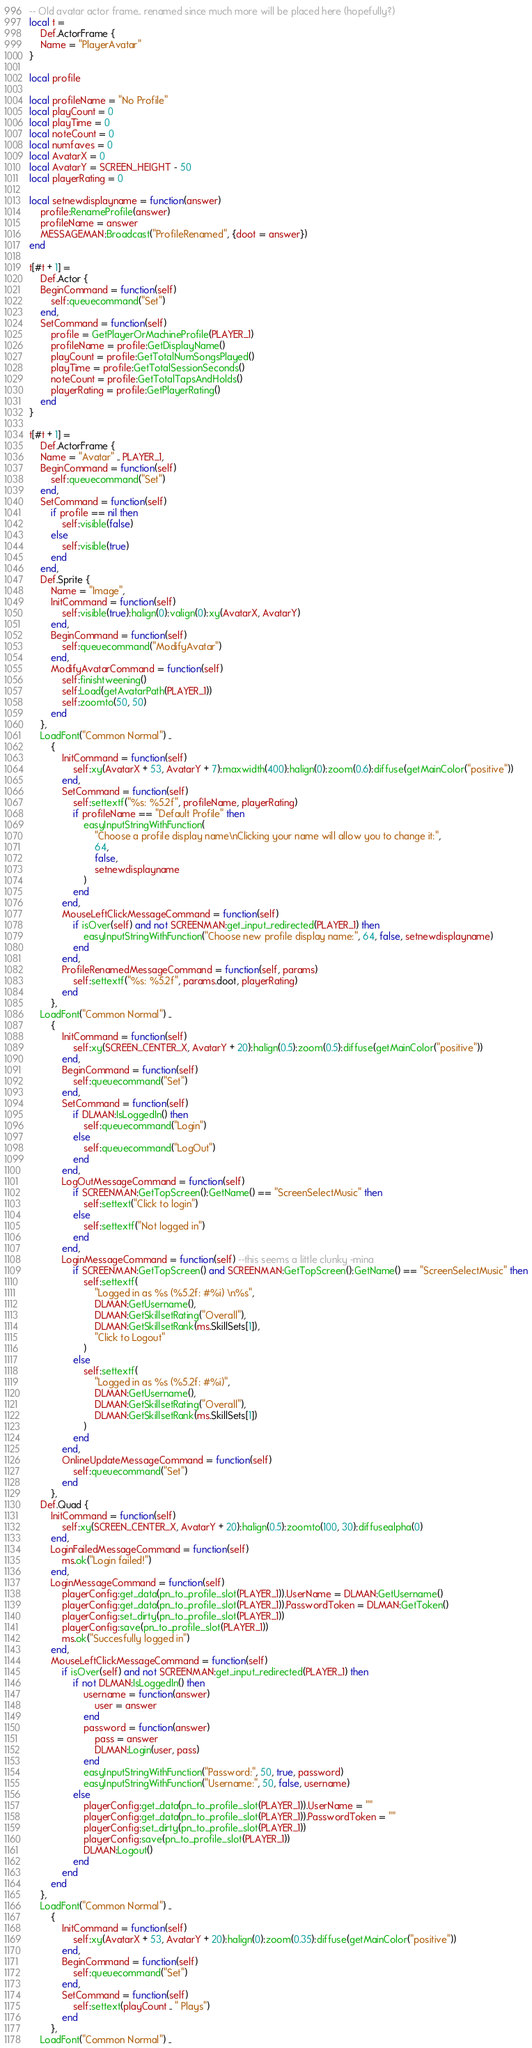<code> <loc_0><loc_0><loc_500><loc_500><_Lua_>-- Old avatar actor frame.. renamed since much more will be placed here (hopefully?)
local t =
	Def.ActorFrame {
	Name = "PlayerAvatar"
}

local profile

local profileName = "No Profile"
local playCount = 0
local playTime = 0
local noteCount = 0
local numfaves = 0
local AvatarX = 0
local AvatarY = SCREEN_HEIGHT - 50
local playerRating = 0

local setnewdisplayname = function(answer)
	profile:RenameProfile(answer)
	profileName = answer
	MESSAGEMAN:Broadcast("ProfileRenamed", {doot = answer})
end

t[#t + 1] =
	Def.Actor {
	BeginCommand = function(self)
		self:queuecommand("Set")
	end,
	SetCommand = function(self)
		profile = GetPlayerOrMachineProfile(PLAYER_1)
		profileName = profile:GetDisplayName()
		playCount = profile:GetTotalNumSongsPlayed()
		playTime = profile:GetTotalSessionSeconds()
		noteCount = profile:GetTotalTapsAndHolds()
		playerRating = profile:GetPlayerRating()
	end
}

t[#t + 1] =
	Def.ActorFrame {
	Name = "Avatar" .. PLAYER_1,
	BeginCommand = function(self)
		self:queuecommand("Set")
	end,
	SetCommand = function(self)
		if profile == nil then
			self:visible(false)
		else
			self:visible(true)
		end
	end,
	Def.Sprite {
		Name = "Image",
		InitCommand = function(self)
			self:visible(true):halign(0):valign(0):xy(AvatarX, AvatarY)
		end,
		BeginCommand = function(self)
			self:queuecommand("ModifyAvatar")
		end,
		ModifyAvatarCommand = function(self)
			self:finishtweening()
			self:Load(getAvatarPath(PLAYER_1))
			self:zoomto(50, 50)
		end
	},
	LoadFont("Common Normal") ..
		{
			InitCommand = function(self)
				self:xy(AvatarX + 53, AvatarY + 7):maxwidth(400):halign(0):zoom(0.6):diffuse(getMainColor("positive"))
			end,
			SetCommand = function(self)
				self:settextf("%s: %5.2f", profileName, playerRating)
				if profileName == "Default Profile" then
					easyInputStringWithFunction(
						"Choose a profile display name\nClicking your name will allow you to change it:",
						64,
						false,
						setnewdisplayname
					)
				end
			end,
			MouseLeftClickMessageCommand = function(self)
				if isOver(self) and not SCREENMAN:get_input_redirected(PLAYER_1) then
					easyInputStringWithFunction("Choose new profile display name:", 64, false, setnewdisplayname)
				end
			end,
			ProfileRenamedMessageCommand = function(self, params)
				self:settextf("%s: %5.2f", params.doot, playerRating)
			end
		},
	LoadFont("Common Normal") ..
		{
			InitCommand = function(self)
				self:xy(SCREEN_CENTER_X, AvatarY + 20):halign(0.5):zoom(0.5):diffuse(getMainColor("positive"))
			end,
			BeginCommand = function(self)
				self:queuecommand("Set")
			end,
			SetCommand = function(self)
				if DLMAN:IsLoggedIn() then
					self:queuecommand("Login")
				else
					self:queuecommand("LogOut")
				end
			end,
			LogOutMessageCommand = function(self)
				if SCREENMAN:GetTopScreen():GetName() == "ScreenSelectMusic" then
					self:settext("Click to login")
				else
					self:settextf("Not logged in")
				end
			end,
			LoginMessageCommand = function(self) --this seems a little clunky -mina
				if SCREENMAN:GetTopScreen() and SCREENMAN:GetTopScreen():GetName() == "ScreenSelectMusic" then
					self:settextf(
						"Logged in as %s (%5.2f: #%i) \n%s",
						DLMAN:GetUsername(),
						DLMAN:GetSkillsetRating("Overall"),
						DLMAN:GetSkillsetRank(ms.SkillSets[1]),
						"Click to Logout"
					)
				else
					self:settextf(
						"Logged in as %s (%5.2f: #%i)",
						DLMAN:GetUsername(),
						DLMAN:GetSkillsetRating("Overall"),
						DLMAN:GetSkillsetRank(ms.SkillSets[1])
					)
				end
			end,
			OnlineUpdateMessageCommand = function(self)
				self:queuecommand("Set")
			end
		},
	Def.Quad {
		InitCommand = function(self)
			self:xy(SCREEN_CENTER_X, AvatarY + 20):halign(0.5):zoomto(100, 30):diffusealpha(0)
		end,
		LoginFailedMessageCommand = function(self)
			ms.ok("Login failed!")
		end,
		LoginMessageCommand = function(self)
			playerConfig:get_data(pn_to_profile_slot(PLAYER_1)).UserName = DLMAN:GetUsername()
			playerConfig:get_data(pn_to_profile_slot(PLAYER_1)).PasswordToken = DLMAN:GetToken()
			playerConfig:set_dirty(pn_to_profile_slot(PLAYER_1))
			playerConfig:save(pn_to_profile_slot(PLAYER_1))
			ms.ok("Succesfully logged in")
		end,
		MouseLeftClickMessageCommand = function(self)
			if isOver(self) and not SCREENMAN:get_input_redirected(PLAYER_1) then
				if not DLMAN:IsLoggedIn() then
					username = function(answer)
						user = answer
					end
					password = function(answer)
						pass = answer
						DLMAN:Login(user, pass)
					end
					easyInputStringWithFunction("Password:", 50, true, password)
					easyInputStringWithFunction("Username:", 50, false, username)
				else
					playerConfig:get_data(pn_to_profile_slot(PLAYER_1)).UserName = ""
					playerConfig:get_data(pn_to_profile_slot(PLAYER_1)).PasswordToken = ""
					playerConfig:set_dirty(pn_to_profile_slot(PLAYER_1))
					playerConfig:save(pn_to_profile_slot(PLAYER_1))
					DLMAN:Logout()
				end
			end
		end
	},
	LoadFont("Common Normal") ..
		{
			InitCommand = function(self)
				self:xy(AvatarX + 53, AvatarY + 20):halign(0):zoom(0.35):diffuse(getMainColor("positive"))
			end,
			BeginCommand = function(self)
				self:queuecommand("Set")
			end,
			SetCommand = function(self)
				self:settext(playCount .. " Plays")
			end
		},
	LoadFont("Common Normal") ..</code> 